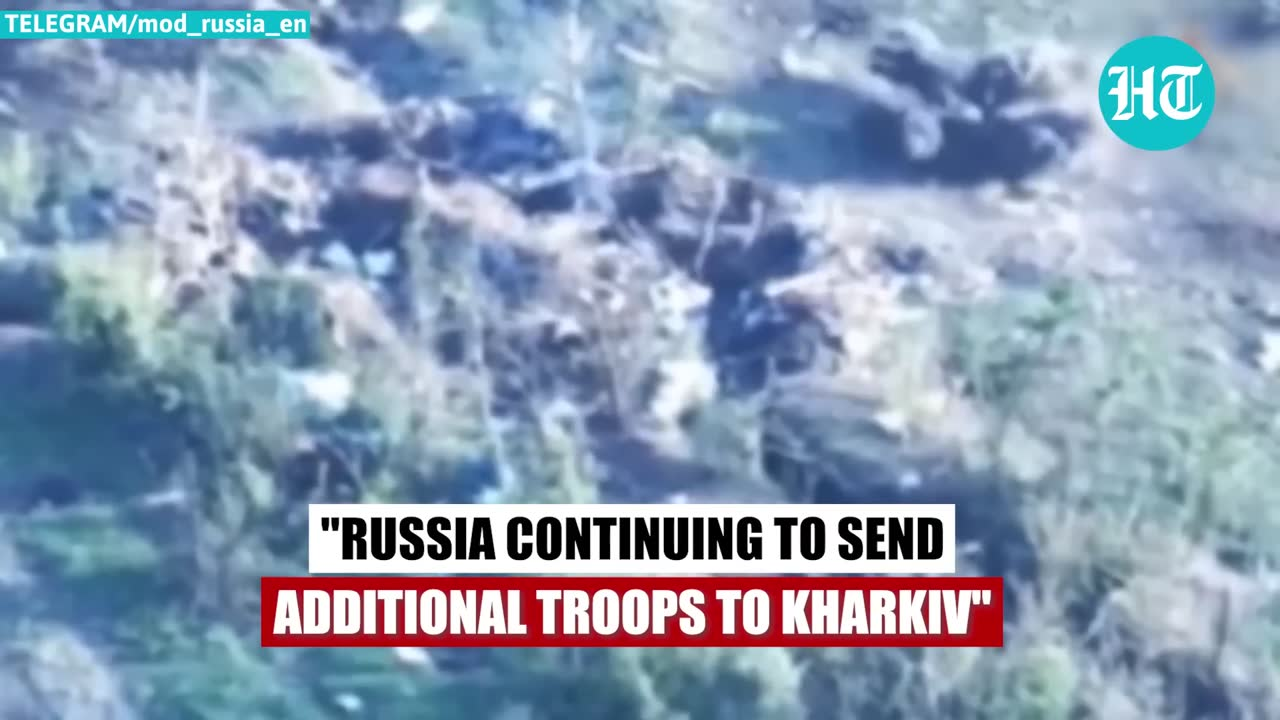describe the img The image shows a cloudy, dramatic sky with dark, stormy clouds. There is no identifiable human face or person visible in the image. The text overlaid on the image states "RUSSIA CONTINUING TO SEND ADDITIONAL TROOPS TO KHARKIV", suggesting this image is related to a military or geopolitical situation in the region of Kharkiv, Ukraine. 